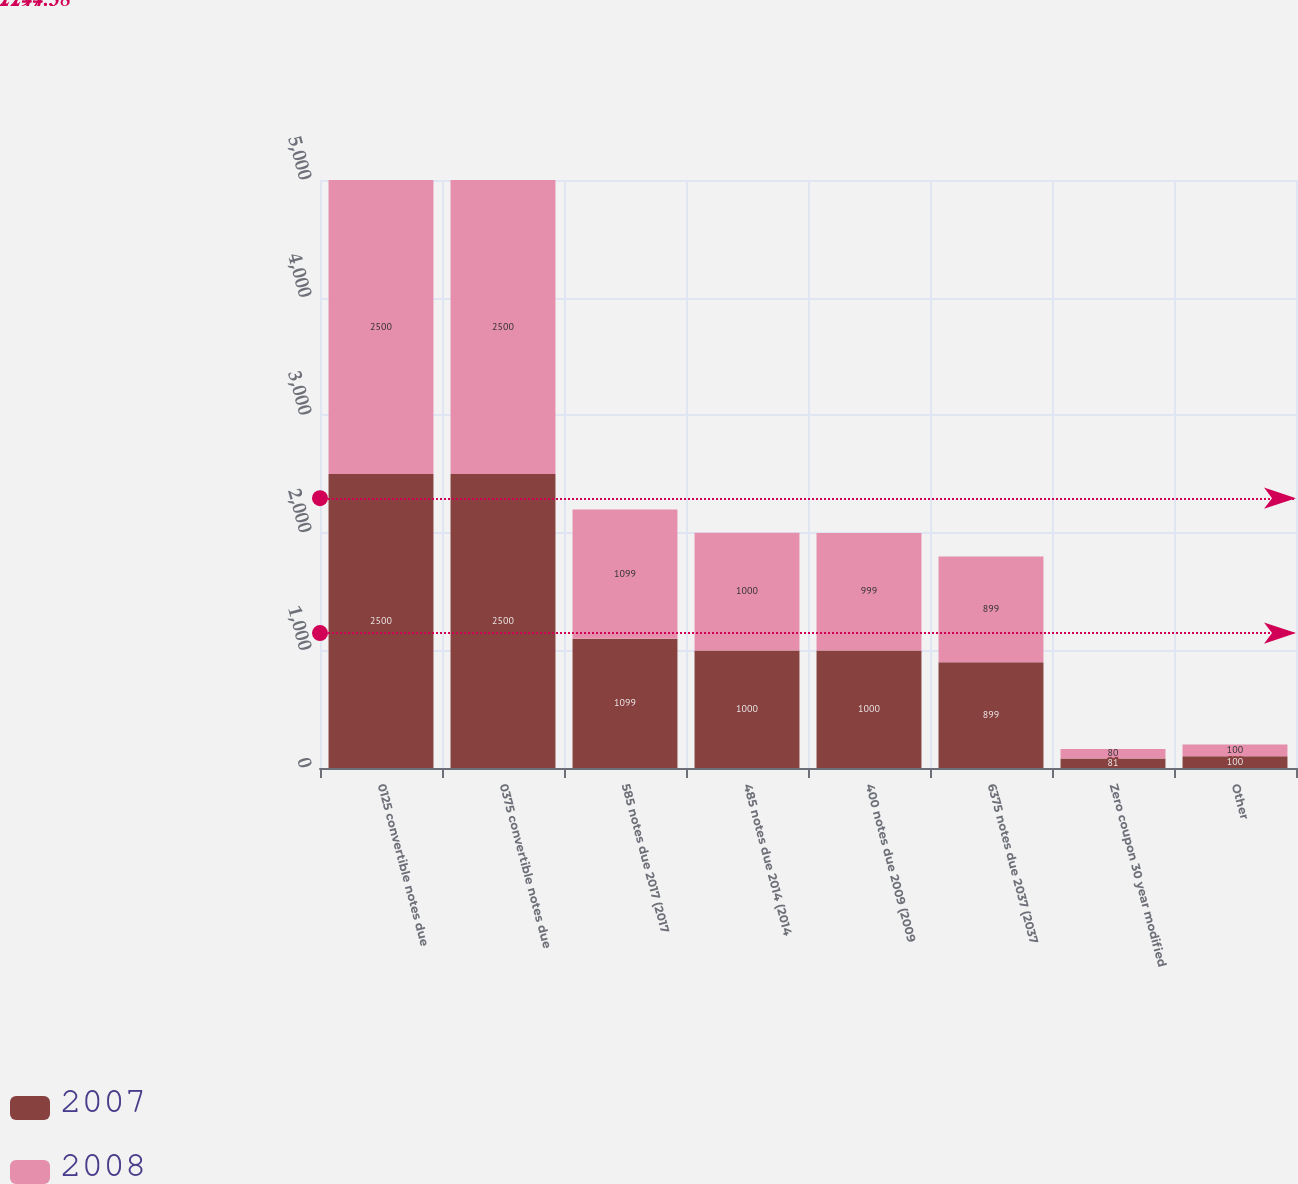Convert chart to OTSL. <chart><loc_0><loc_0><loc_500><loc_500><stacked_bar_chart><ecel><fcel>0125 convertible notes due<fcel>0375 convertible notes due<fcel>585 notes due 2017 (2017<fcel>485 notes due 2014 (2014<fcel>400 notes due 2009 (2009<fcel>6375 notes due 2037 (2037<fcel>Zero coupon 30 year modified<fcel>Other<nl><fcel>2007<fcel>2500<fcel>2500<fcel>1099<fcel>1000<fcel>1000<fcel>899<fcel>81<fcel>100<nl><fcel>2008<fcel>2500<fcel>2500<fcel>1099<fcel>1000<fcel>999<fcel>899<fcel>80<fcel>100<nl></chart> 